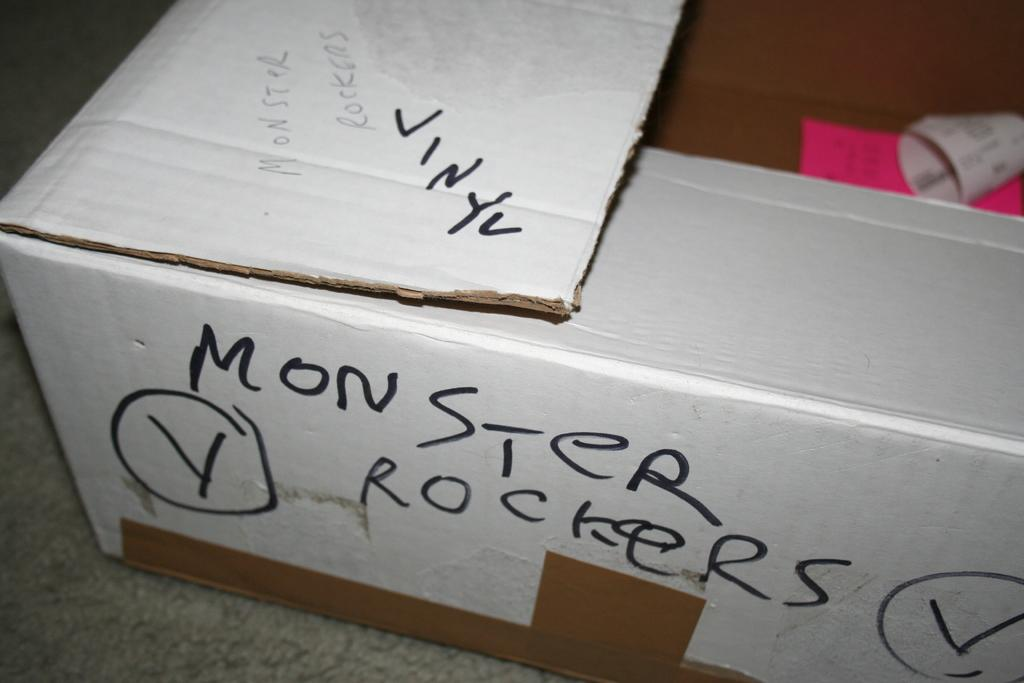Provide a one-sentence caption for the provided image. A white box has Monster Rockers written on the side in black marker. 